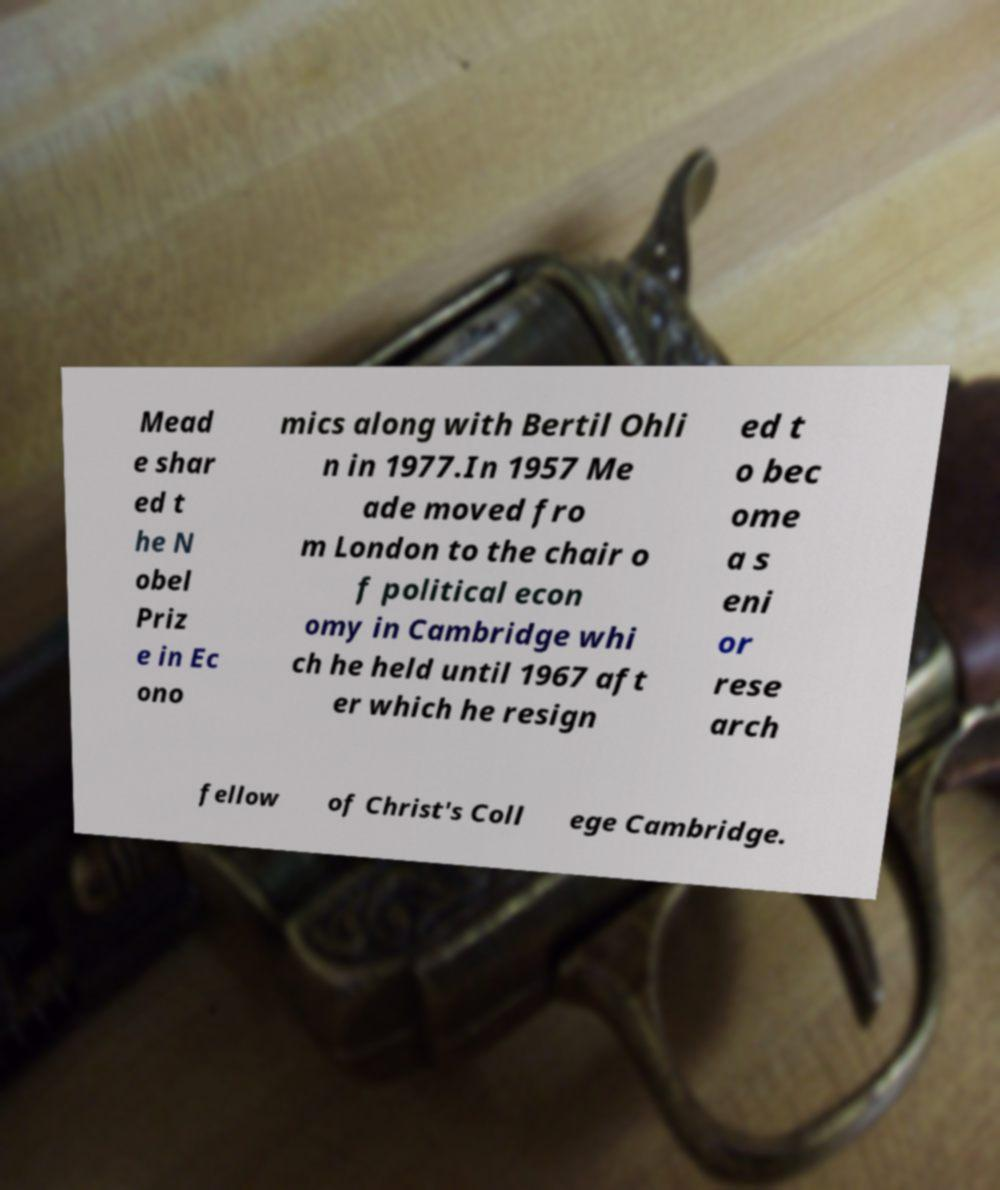Could you extract and type out the text from this image? Mead e shar ed t he N obel Priz e in Ec ono mics along with Bertil Ohli n in 1977.In 1957 Me ade moved fro m London to the chair o f political econ omy in Cambridge whi ch he held until 1967 aft er which he resign ed t o bec ome a s eni or rese arch fellow of Christ's Coll ege Cambridge. 